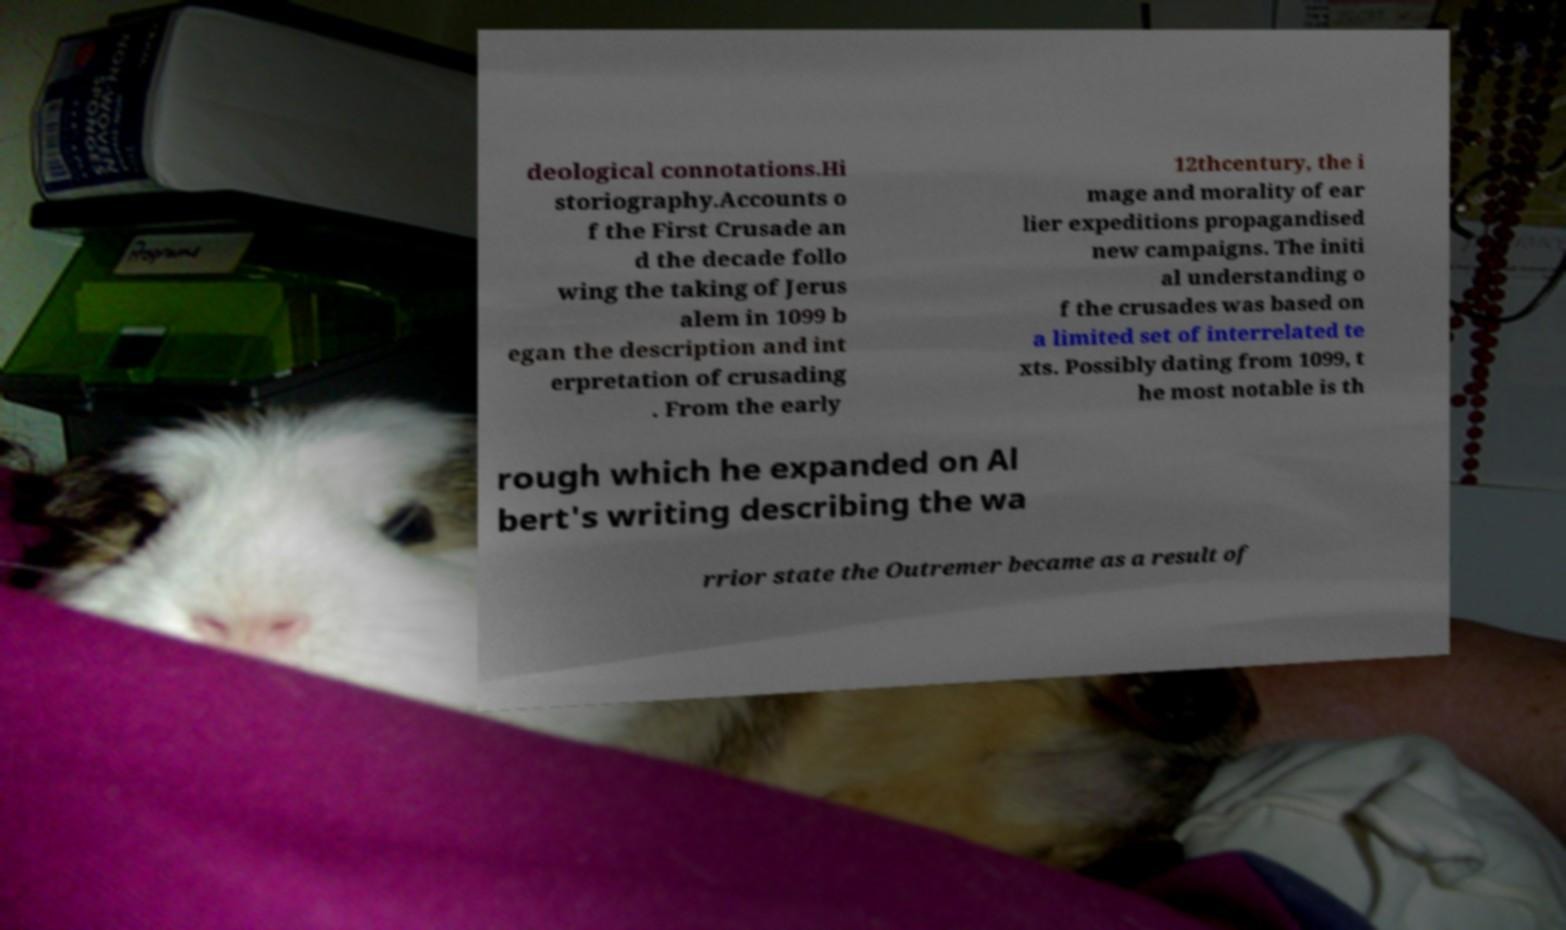I need the written content from this picture converted into text. Can you do that? deological connotations.Hi storiography.Accounts o f the First Crusade an d the decade follo wing the taking of Jerus alem in 1099 b egan the description and int erpretation of crusading . From the early 12thcentury, the i mage and morality of ear lier expeditions propagandised new campaigns. The initi al understanding o f the crusades was based on a limited set of interrelated te xts. Possibly dating from 1099, t he most notable is th rough which he expanded on Al bert's writing describing the wa rrior state the Outremer became as a result of 